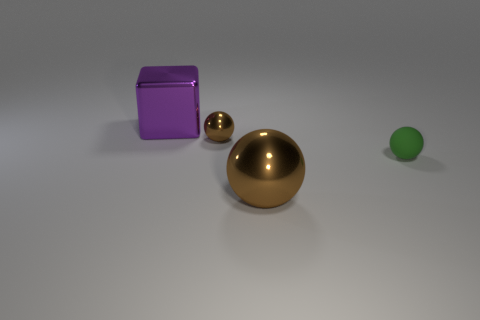Are the brown object in front of the green rubber object and the ball that is behind the green matte ball made of the same material?
Provide a short and direct response. Yes. How many brown shiny things have the same size as the cube?
Provide a short and direct response. 1. There is a big object that is in front of the big purple shiny cube; what material is it?
Your answer should be compact. Metal. How many big brown objects are the same shape as the purple shiny object?
Provide a short and direct response. 0. What is the shape of the brown thing that is the same material as the large brown ball?
Give a very brief answer. Sphere. There is a large shiny thing on the left side of the big metallic object in front of the big object that is on the left side of the big brown sphere; what shape is it?
Offer a terse response. Cube. Are there more shiny balls than rubber objects?
Keep it short and to the point. Yes. What material is the other tiny object that is the same shape as the tiny green rubber object?
Ensure brevity in your answer.  Metal. Is the material of the large brown object the same as the tiny brown thing?
Provide a short and direct response. Yes. Are there more big brown things left of the tiny green rubber object than small brown metallic objects?
Make the answer very short. No. 